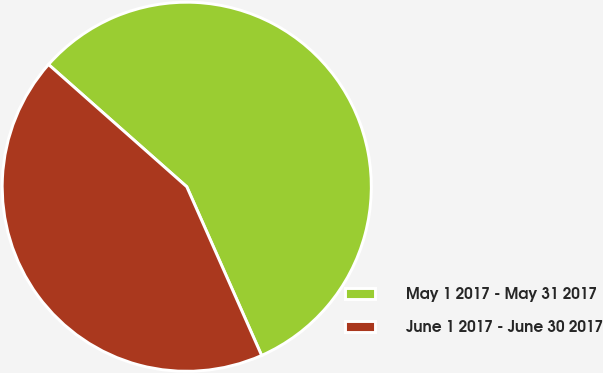Convert chart to OTSL. <chart><loc_0><loc_0><loc_500><loc_500><pie_chart><fcel>May 1 2017 - May 31 2017<fcel>June 1 2017 - June 30 2017<nl><fcel>56.83%<fcel>43.17%<nl></chart> 